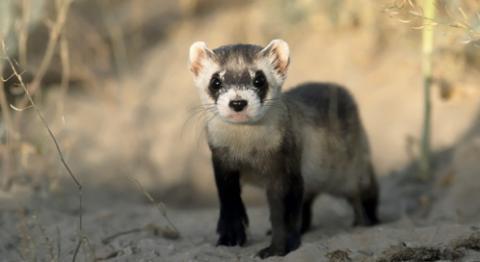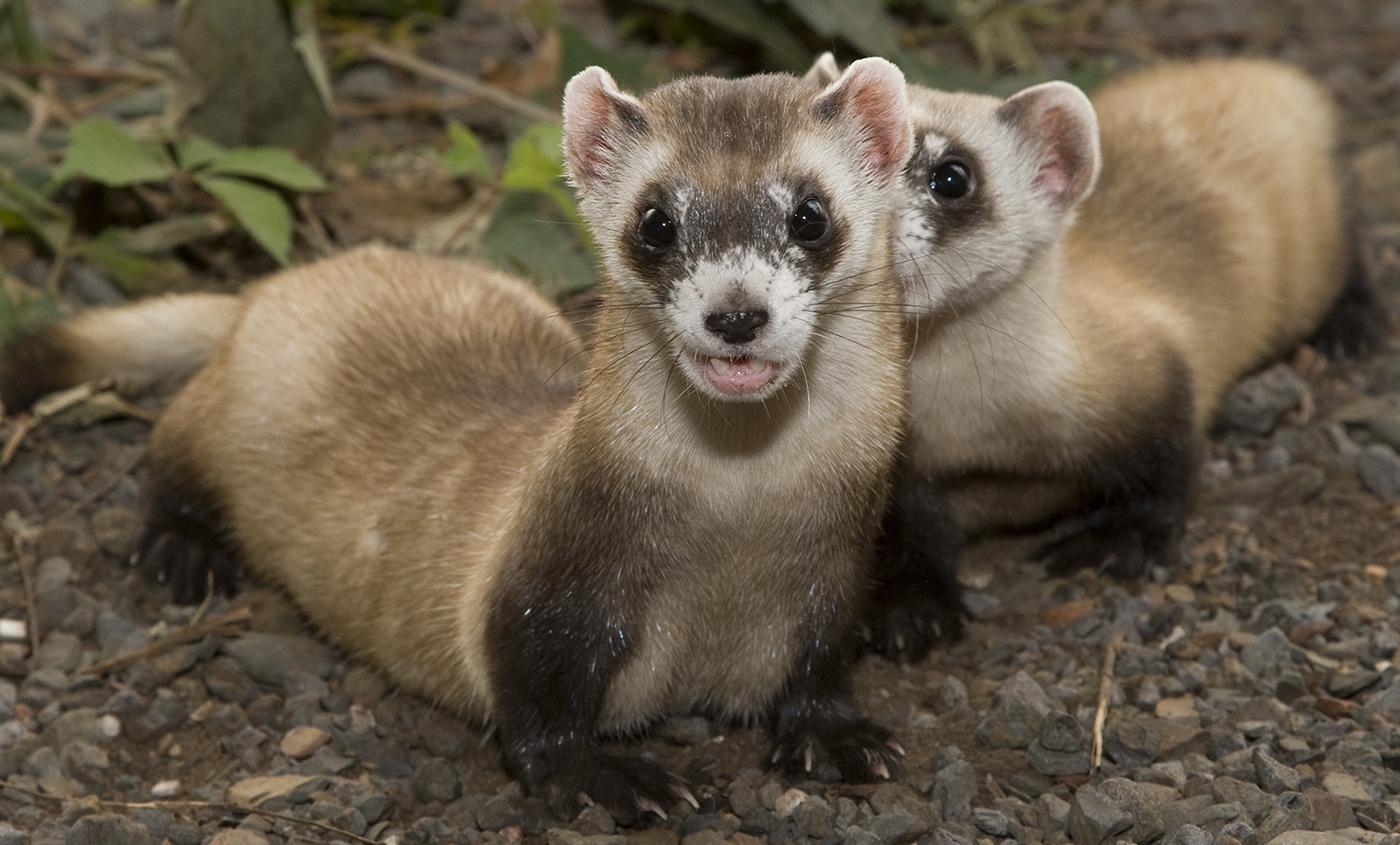The first image is the image on the left, the second image is the image on the right. Analyze the images presented: Is the assertion "In one of the photos, the animal has its mouth wide open." valid? Answer yes or no. No. The first image is the image on the left, the second image is the image on the right. Analyze the images presented: Is the assertion "in one image there is a lone black footed ferret looking out from a hole in the ground." valid? Answer yes or no. No. 